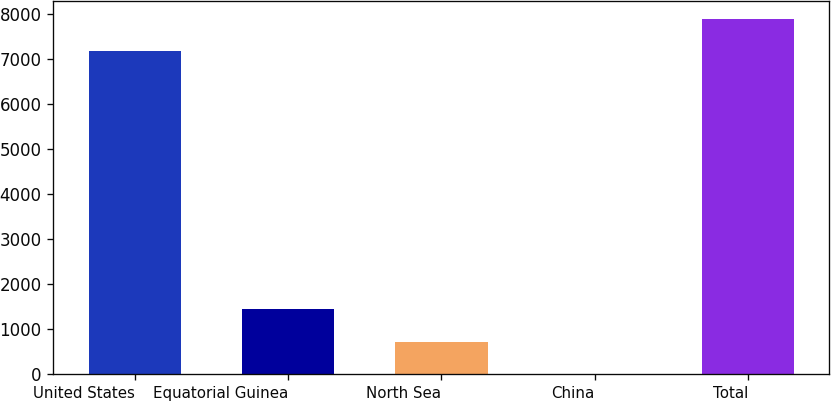Convert chart to OTSL. <chart><loc_0><loc_0><loc_500><loc_500><bar_chart><fcel>United States<fcel>Equatorial Guinea<fcel>North Sea<fcel>China<fcel>Total<nl><fcel>7181<fcel>1442.4<fcel>721.7<fcel>1<fcel>7901.7<nl></chart> 